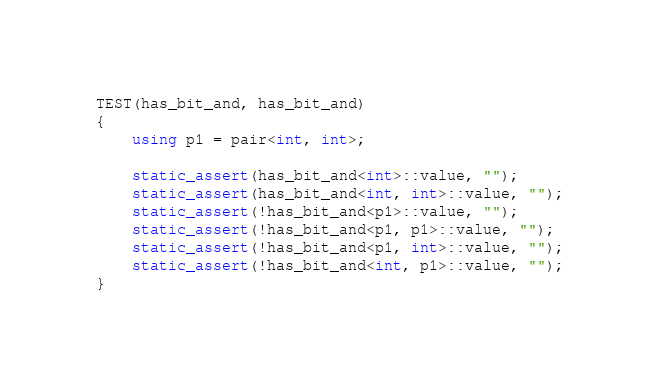Convert code to text. <code><loc_0><loc_0><loc_500><loc_500><_C++_>
TEST(has_bit_and, has_bit_and)
{
    using p1 = pair<int, int>;

    static_assert(has_bit_and<int>::value, "");
    static_assert(has_bit_and<int, int>::value, "");
    static_assert(!has_bit_and<p1>::value, "");
    static_assert(!has_bit_and<p1, p1>::value, "");
    static_assert(!has_bit_and<p1, int>::value, "");
    static_assert(!has_bit_and<int, p1>::value, "");
}
</code> 